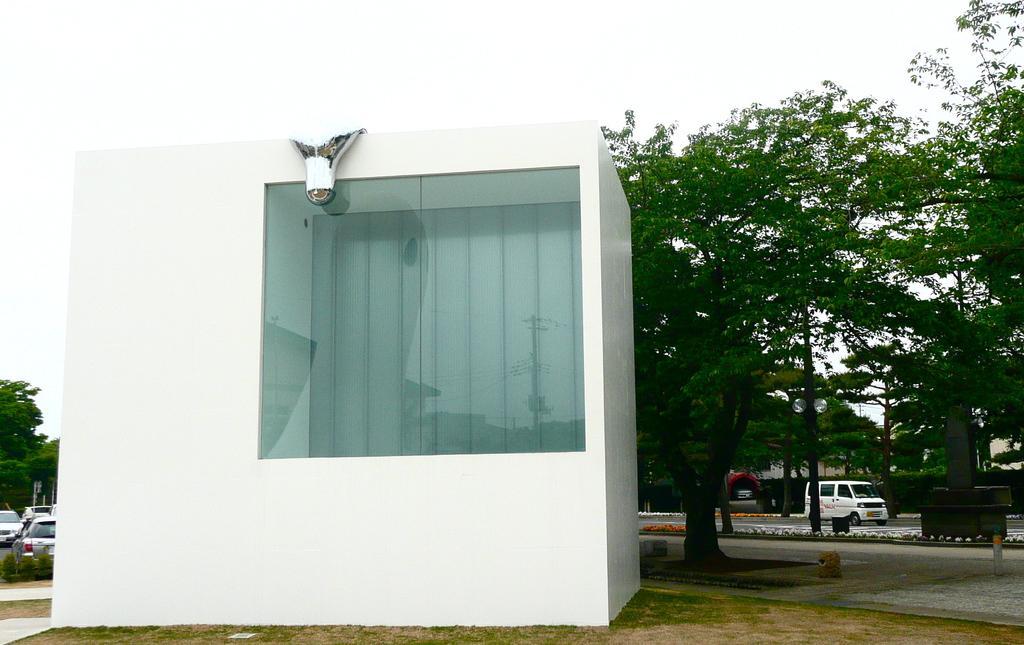Can you describe this image briefly? In this image we can see there are vehicles on the road. There is a room with glass and light. And there are trees, poles, grass and the sky. 